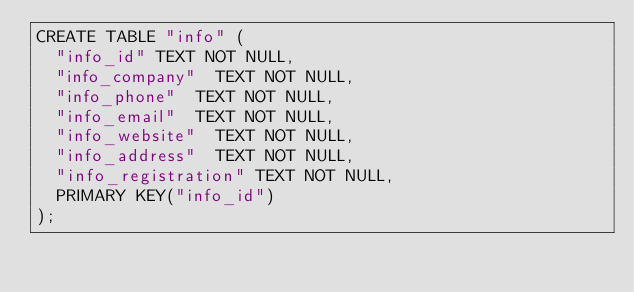<code> <loc_0><loc_0><loc_500><loc_500><_SQL_>CREATE TABLE "info" (
	"info_id"	TEXT NOT NULL,
	"info_company"	TEXT NOT NULL,
	"info_phone"	TEXT NOT NULL,
	"info_email"	TEXT NOT NULL,
	"info_website"	TEXT NOT NULL,
	"info_address"	TEXT NOT NULL,
	"info_registration"	TEXT NOT NULL,
	PRIMARY KEY("info_id")
);</code> 